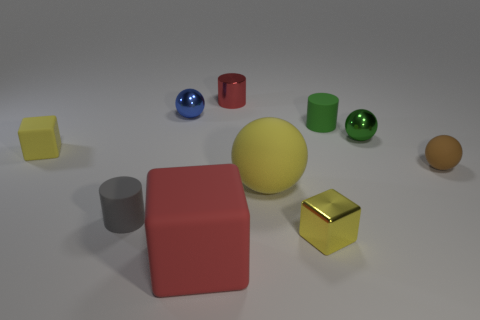Subtract all tiny rubber cylinders. How many cylinders are left? 1 Subtract 4 spheres. How many spheres are left? 0 Subtract all red cylinders. How many cylinders are left? 2 Add 1 metallic things. How many metallic things are left? 5 Add 8 small red metallic objects. How many small red metallic objects exist? 9 Subtract 0 cyan cubes. How many objects are left? 10 Subtract all cubes. How many objects are left? 7 Subtract all red cylinders. Subtract all purple cubes. How many cylinders are left? 2 Subtract all cyan spheres. How many yellow cylinders are left? 0 Subtract all brown balls. Subtract all green spheres. How many objects are left? 8 